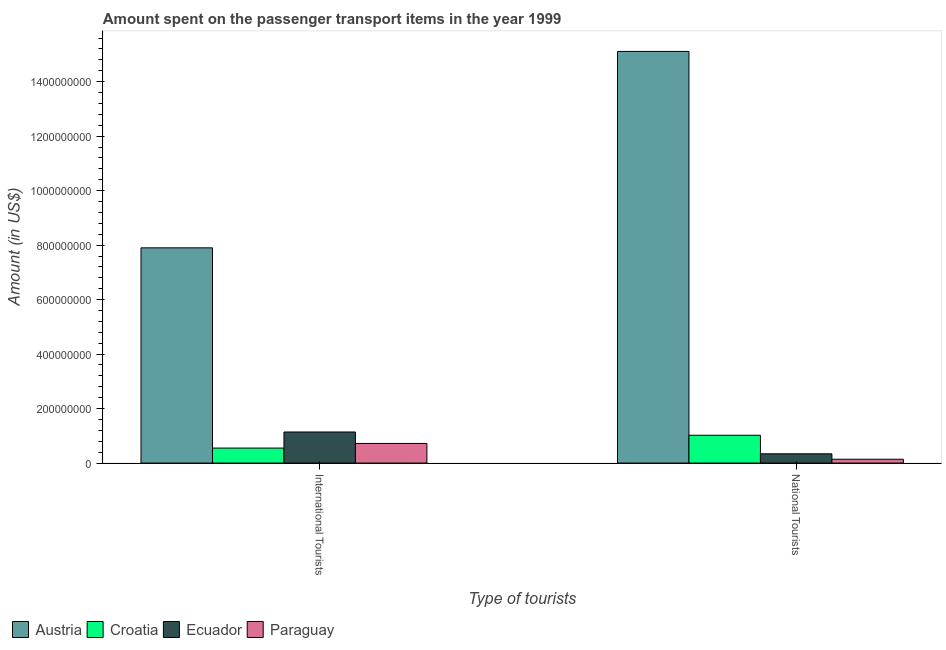How many groups of bars are there?
Provide a short and direct response. 2. Are the number of bars per tick equal to the number of legend labels?
Ensure brevity in your answer.  Yes. How many bars are there on the 1st tick from the right?
Give a very brief answer. 4. What is the label of the 2nd group of bars from the left?
Ensure brevity in your answer.  National Tourists. What is the amount spent on transport items of international tourists in Austria?
Ensure brevity in your answer.  7.90e+08. Across all countries, what is the maximum amount spent on transport items of national tourists?
Ensure brevity in your answer.  1.51e+09. Across all countries, what is the minimum amount spent on transport items of national tourists?
Provide a short and direct response. 1.40e+07. In which country was the amount spent on transport items of national tourists minimum?
Your answer should be very brief. Paraguay. What is the total amount spent on transport items of national tourists in the graph?
Offer a very short reply. 1.66e+09. What is the difference between the amount spent on transport items of national tourists in Paraguay and that in Austria?
Provide a short and direct response. -1.50e+09. What is the difference between the amount spent on transport items of national tourists in Croatia and the amount spent on transport items of international tourists in Ecuador?
Give a very brief answer. -1.20e+07. What is the average amount spent on transport items of national tourists per country?
Offer a very short reply. 4.15e+08. What is the difference between the amount spent on transport items of national tourists and amount spent on transport items of international tourists in Ecuador?
Provide a succinct answer. -8.00e+07. What is the ratio of the amount spent on transport items of international tourists in Austria to that in Ecuador?
Ensure brevity in your answer.  6.93. Is the amount spent on transport items of international tourists in Croatia less than that in Austria?
Your response must be concise. Yes. What does the 2nd bar from the left in International Tourists represents?
Your answer should be compact. Croatia. What does the 1st bar from the right in International Tourists represents?
Your answer should be very brief. Paraguay. How many bars are there?
Your answer should be very brief. 8. How many countries are there in the graph?
Give a very brief answer. 4. Are the values on the major ticks of Y-axis written in scientific E-notation?
Offer a terse response. No. Does the graph contain any zero values?
Ensure brevity in your answer.  No. Where does the legend appear in the graph?
Ensure brevity in your answer.  Bottom left. How are the legend labels stacked?
Keep it short and to the point. Horizontal. What is the title of the graph?
Offer a very short reply. Amount spent on the passenger transport items in the year 1999. What is the label or title of the X-axis?
Provide a short and direct response. Type of tourists. What is the label or title of the Y-axis?
Your answer should be very brief. Amount (in US$). What is the Amount (in US$) of Austria in International Tourists?
Offer a very short reply. 7.90e+08. What is the Amount (in US$) in Croatia in International Tourists?
Offer a terse response. 5.50e+07. What is the Amount (in US$) of Ecuador in International Tourists?
Ensure brevity in your answer.  1.14e+08. What is the Amount (in US$) of Paraguay in International Tourists?
Ensure brevity in your answer.  7.20e+07. What is the Amount (in US$) of Austria in National Tourists?
Offer a very short reply. 1.51e+09. What is the Amount (in US$) in Croatia in National Tourists?
Ensure brevity in your answer.  1.02e+08. What is the Amount (in US$) of Ecuador in National Tourists?
Offer a terse response. 3.40e+07. What is the Amount (in US$) in Paraguay in National Tourists?
Give a very brief answer. 1.40e+07. Across all Type of tourists, what is the maximum Amount (in US$) in Austria?
Your answer should be compact. 1.51e+09. Across all Type of tourists, what is the maximum Amount (in US$) in Croatia?
Offer a very short reply. 1.02e+08. Across all Type of tourists, what is the maximum Amount (in US$) of Ecuador?
Provide a short and direct response. 1.14e+08. Across all Type of tourists, what is the maximum Amount (in US$) in Paraguay?
Offer a terse response. 7.20e+07. Across all Type of tourists, what is the minimum Amount (in US$) of Austria?
Provide a succinct answer. 7.90e+08. Across all Type of tourists, what is the minimum Amount (in US$) of Croatia?
Ensure brevity in your answer.  5.50e+07. Across all Type of tourists, what is the minimum Amount (in US$) in Ecuador?
Ensure brevity in your answer.  3.40e+07. Across all Type of tourists, what is the minimum Amount (in US$) of Paraguay?
Your answer should be compact. 1.40e+07. What is the total Amount (in US$) of Austria in the graph?
Your response must be concise. 2.30e+09. What is the total Amount (in US$) of Croatia in the graph?
Your answer should be compact. 1.57e+08. What is the total Amount (in US$) of Ecuador in the graph?
Give a very brief answer. 1.48e+08. What is the total Amount (in US$) in Paraguay in the graph?
Provide a succinct answer. 8.60e+07. What is the difference between the Amount (in US$) of Austria in International Tourists and that in National Tourists?
Give a very brief answer. -7.21e+08. What is the difference between the Amount (in US$) of Croatia in International Tourists and that in National Tourists?
Make the answer very short. -4.70e+07. What is the difference between the Amount (in US$) in Ecuador in International Tourists and that in National Tourists?
Give a very brief answer. 8.00e+07. What is the difference between the Amount (in US$) of Paraguay in International Tourists and that in National Tourists?
Make the answer very short. 5.80e+07. What is the difference between the Amount (in US$) in Austria in International Tourists and the Amount (in US$) in Croatia in National Tourists?
Your answer should be compact. 6.88e+08. What is the difference between the Amount (in US$) of Austria in International Tourists and the Amount (in US$) of Ecuador in National Tourists?
Give a very brief answer. 7.56e+08. What is the difference between the Amount (in US$) in Austria in International Tourists and the Amount (in US$) in Paraguay in National Tourists?
Give a very brief answer. 7.76e+08. What is the difference between the Amount (in US$) of Croatia in International Tourists and the Amount (in US$) of Ecuador in National Tourists?
Ensure brevity in your answer.  2.10e+07. What is the difference between the Amount (in US$) in Croatia in International Tourists and the Amount (in US$) in Paraguay in National Tourists?
Make the answer very short. 4.10e+07. What is the difference between the Amount (in US$) of Ecuador in International Tourists and the Amount (in US$) of Paraguay in National Tourists?
Ensure brevity in your answer.  1.00e+08. What is the average Amount (in US$) of Austria per Type of tourists?
Keep it short and to the point. 1.15e+09. What is the average Amount (in US$) in Croatia per Type of tourists?
Your answer should be very brief. 7.85e+07. What is the average Amount (in US$) in Ecuador per Type of tourists?
Keep it short and to the point. 7.40e+07. What is the average Amount (in US$) of Paraguay per Type of tourists?
Ensure brevity in your answer.  4.30e+07. What is the difference between the Amount (in US$) of Austria and Amount (in US$) of Croatia in International Tourists?
Your answer should be compact. 7.35e+08. What is the difference between the Amount (in US$) of Austria and Amount (in US$) of Ecuador in International Tourists?
Offer a very short reply. 6.76e+08. What is the difference between the Amount (in US$) of Austria and Amount (in US$) of Paraguay in International Tourists?
Your answer should be very brief. 7.18e+08. What is the difference between the Amount (in US$) of Croatia and Amount (in US$) of Ecuador in International Tourists?
Your response must be concise. -5.90e+07. What is the difference between the Amount (in US$) in Croatia and Amount (in US$) in Paraguay in International Tourists?
Your answer should be very brief. -1.70e+07. What is the difference between the Amount (in US$) of Ecuador and Amount (in US$) of Paraguay in International Tourists?
Make the answer very short. 4.20e+07. What is the difference between the Amount (in US$) in Austria and Amount (in US$) in Croatia in National Tourists?
Offer a very short reply. 1.41e+09. What is the difference between the Amount (in US$) in Austria and Amount (in US$) in Ecuador in National Tourists?
Keep it short and to the point. 1.48e+09. What is the difference between the Amount (in US$) of Austria and Amount (in US$) of Paraguay in National Tourists?
Offer a very short reply. 1.50e+09. What is the difference between the Amount (in US$) in Croatia and Amount (in US$) in Ecuador in National Tourists?
Give a very brief answer. 6.80e+07. What is the difference between the Amount (in US$) in Croatia and Amount (in US$) in Paraguay in National Tourists?
Provide a succinct answer. 8.80e+07. What is the ratio of the Amount (in US$) in Austria in International Tourists to that in National Tourists?
Provide a short and direct response. 0.52. What is the ratio of the Amount (in US$) of Croatia in International Tourists to that in National Tourists?
Make the answer very short. 0.54. What is the ratio of the Amount (in US$) in Ecuador in International Tourists to that in National Tourists?
Provide a succinct answer. 3.35. What is the ratio of the Amount (in US$) of Paraguay in International Tourists to that in National Tourists?
Your answer should be compact. 5.14. What is the difference between the highest and the second highest Amount (in US$) of Austria?
Keep it short and to the point. 7.21e+08. What is the difference between the highest and the second highest Amount (in US$) of Croatia?
Provide a succinct answer. 4.70e+07. What is the difference between the highest and the second highest Amount (in US$) in Ecuador?
Offer a terse response. 8.00e+07. What is the difference between the highest and the second highest Amount (in US$) in Paraguay?
Offer a very short reply. 5.80e+07. What is the difference between the highest and the lowest Amount (in US$) in Austria?
Your response must be concise. 7.21e+08. What is the difference between the highest and the lowest Amount (in US$) in Croatia?
Offer a terse response. 4.70e+07. What is the difference between the highest and the lowest Amount (in US$) in Ecuador?
Ensure brevity in your answer.  8.00e+07. What is the difference between the highest and the lowest Amount (in US$) in Paraguay?
Offer a terse response. 5.80e+07. 